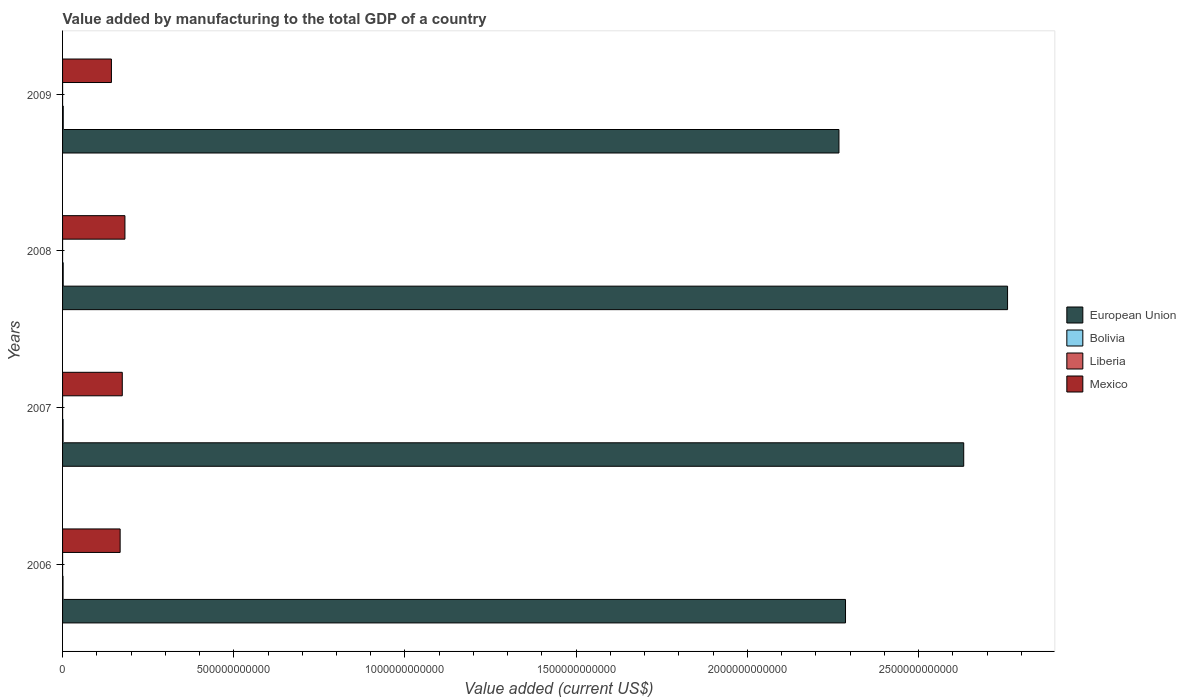How many different coloured bars are there?
Make the answer very short. 4. How many groups of bars are there?
Your answer should be very brief. 4. Are the number of bars per tick equal to the number of legend labels?
Provide a short and direct response. Yes. How many bars are there on the 3rd tick from the top?
Your response must be concise. 4. How many bars are there on the 4th tick from the bottom?
Provide a short and direct response. 4. What is the value added by manufacturing to the total GDP in Liberia in 2007?
Your answer should be compact. 5.42e+07. Across all years, what is the maximum value added by manufacturing to the total GDP in Liberia?
Your answer should be compact. 5.42e+07. Across all years, what is the minimum value added by manufacturing to the total GDP in Bolivia?
Make the answer very short. 1.30e+09. In which year was the value added by manufacturing to the total GDP in Bolivia minimum?
Make the answer very short. 2006. What is the total value added by manufacturing to the total GDP in Mexico in the graph?
Your answer should be very brief. 6.67e+11. What is the difference between the value added by manufacturing to the total GDP in Mexico in 2006 and that in 2009?
Your response must be concise. 2.54e+1. What is the difference between the value added by manufacturing to the total GDP in European Union in 2009 and the value added by manufacturing to the total GDP in Bolivia in 2008?
Ensure brevity in your answer.  2.27e+12. What is the average value added by manufacturing to the total GDP in European Union per year?
Ensure brevity in your answer.  2.49e+12. In the year 2008, what is the difference between the value added by manufacturing to the total GDP in Mexico and value added by manufacturing to the total GDP in European Union?
Keep it short and to the point. -2.58e+12. In how many years, is the value added by manufacturing to the total GDP in Bolivia greater than 1000000000000 US$?
Your answer should be compact. 0. What is the ratio of the value added by manufacturing to the total GDP in Bolivia in 2007 to that in 2009?
Provide a succinct answer. 0.74. What is the difference between the highest and the second highest value added by manufacturing to the total GDP in Mexico?
Offer a very short reply. 7.74e+09. What is the difference between the highest and the lowest value added by manufacturing to the total GDP in Liberia?
Keep it short and to the point. 8.43e+06. Is the sum of the value added by manufacturing to the total GDP in Bolivia in 2007 and 2008 greater than the maximum value added by manufacturing to the total GDP in European Union across all years?
Make the answer very short. No. What does the 3rd bar from the top in 2009 represents?
Provide a succinct answer. Bolivia. What does the 2nd bar from the bottom in 2007 represents?
Make the answer very short. Bolivia. Is it the case that in every year, the sum of the value added by manufacturing to the total GDP in Bolivia and value added by manufacturing to the total GDP in Mexico is greater than the value added by manufacturing to the total GDP in European Union?
Ensure brevity in your answer.  No. What is the difference between two consecutive major ticks on the X-axis?
Your answer should be compact. 5.00e+11. Are the values on the major ticks of X-axis written in scientific E-notation?
Your answer should be compact. No. How are the legend labels stacked?
Ensure brevity in your answer.  Vertical. What is the title of the graph?
Ensure brevity in your answer.  Value added by manufacturing to the total GDP of a country. Does "Suriname" appear as one of the legend labels in the graph?
Keep it short and to the point. No. What is the label or title of the X-axis?
Provide a short and direct response. Value added (current US$). What is the Value added (current US$) of European Union in 2006?
Offer a terse response. 2.29e+12. What is the Value added (current US$) in Bolivia in 2006?
Your response must be concise. 1.30e+09. What is the Value added (current US$) of Liberia in 2006?
Offer a very short reply. 4.58e+07. What is the Value added (current US$) in Mexico in 2006?
Your response must be concise. 1.68e+11. What is the Value added (current US$) in European Union in 2007?
Keep it short and to the point. 2.63e+12. What is the Value added (current US$) of Bolivia in 2007?
Provide a succinct answer. 1.50e+09. What is the Value added (current US$) of Liberia in 2007?
Ensure brevity in your answer.  5.42e+07. What is the Value added (current US$) of Mexico in 2007?
Your response must be concise. 1.74e+11. What is the Value added (current US$) of European Union in 2008?
Give a very brief answer. 2.76e+12. What is the Value added (current US$) in Bolivia in 2008?
Ensure brevity in your answer.  1.86e+09. What is the Value added (current US$) of Liberia in 2008?
Give a very brief answer. 5.11e+07. What is the Value added (current US$) in Mexico in 2008?
Offer a very short reply. 1.82e+11. What is the Value added (current US$) of European Union in 2009?
Your response must be concise. 2.27e+12. What is the Value added (current US$) in Bolivia in 2009?
Make the answer very short. 2.01e+09. What is the Value added (current US$) in Liberia in 2009?
Your answer should be compact. 4.96e+07. What is the Value added (current US$) of Mexico in 2009?
Ensure brevity in your answer.  1.43e+11. Across all years, what is the maximum Value added (current US$) of European Union?
Offer a very short reply. 2.76e+12. Across all years, what is the maximum Value added (current US$) in Bolivia?
Provide a succinct answer. 2.01e+09. Across all years, what is the maximum Value added (current US$) in Liberia?
Offer a terse response. 5.42e+07. Across all years, what is the maximum Value added (current US$) in Mexico?
Provide a short and direct response. 1.82e+11. Across all years, what is the minimum Value added (current US$) in European Union?
Offer a very short reply. 2.27e+12. Across all years, what is the minimum Value added (current US$) in Bolivia?
Your response must be concise. 1.30e+09. Across all years, what is the minimum Value added (current US$) of Liberia?
Keep it short and to the point. 4.58e+07. Across all years, what is the minimum Value added (current US$) in Mexico?
Give a very brief answer. 1.43e+11. What is the total Value added (current US$) in European Union in the graph?
Ensure brevity in your answer.  9.95e+12. What is the total Value added (current US$) of Bolivia in the graph?
Your answer should be compact. 6.67e+09. What is the total Value added (current US$) in Liberia in the graph?
Your response must be concise. 2.01e+08. What is the total Value added (current US$) of Mexico in the graph?
Your answer should be very brief. 6.67e+11. What is the difference between the Value added (current US$) of European Union in 2006 and that in 2007?
Keep it short and to the point. -3.45e+11. What is the difference between the Value added (current US$) of Bolivia in 2006 and that in 2007?
Offer a terse response. -2.00e+08. What is the difference between the Value added (current US$) of Liberia in 2006 and that in 2007?
Make the answer very short. -8.43e+06. What is the difference between the Value added (current US$) of Mexico in 2006 and that in 2007?
Give a very brief answer. -6.27e+09. What is the difference between the Value added (current US$) of European Union in 2006 and that in 2008?
Your response must be concise. -4.73e+11. What is the difference between the Value added (current US$) in Bolivia in 2006 and that in 2008?
Make the answer very short. -5.65e+08. What is the difference between the Value added (current US$) of Liberia in 2006 and that in 2008?
Provide a short and direct response. -5.27e+06. What is the difference between the Value added (current US$) in Mexico in 2006 and that in 2008?
Keep it short and to the point. -1.40e+1. What is the difference between the Value added (current US$) in European Union in 2006 and that in 2009?
Your response must be concise. 1.92e+1. What is the difference between the Value added (current US$) of Bolivia in 2006 and that in 2009?
Offer a terse response. -7.17e+08. What is the difference between the Value added (current US$) in Liberia in 2006 and that in 2009?
Keep it short and to the point. -3.84e+06. What is the difference between the Value added (current US$) of Mexico in 2006 and that in 2009?
Provide a short and direct response. 2.54e+1. What is the difference between the Value added (current US$) of European Union in 2007 and that in 2008?
Your answer should be very brief. -1.28e+11. What is the difference between the Value added (current US$) in Bolivia in 2007 and that in 2008?
Offer a very short reply. -3.65e+08. What is the difference between the Value added (current US$) of Liberia in 2007 and that in 2008?
Your answer should be compact. 3.16e+06. What is the difference between the Value added (current US$) in Mexico in 2007 and that in 2008?
Your answer should be very brief. -7.74e+09. What is the difference between the Value added (current US$) of European Union in 2007 and that in 2009?
Provide a short and direct response. 3.64e+11. What is the difference between the Value added (current US$) of Bolivia in 2007 and that in 2009?
Your answer should be compact. -5.17e+08. What is the difference between the Value added (current US$) of Liberia in 2007 and that in 2009?
Provide a succinct answer. 4.58e+06. What is the difference between the Value added (current US$) in Mexico in 2007 and that in 2009?
Keep it short and to the point. 3.17e+1. What is the difference between the Value added (current US$) in European Union in 2008 and that in 2009?
Keep it short and to the point. 4.93e+11. What is the difference between the Value added (current US$) of Bolivia in 2008 and that in 2009?
Provide a short and direct response. -1.52e+08. What is the difference between the Value added (current US$) in Liberia in 2008 and that in 2009?
Your answer should be compact. 1.42e+06. What is the difference between the Value added (current US$) in Mexico in 2008 and that in 2009?
Make the answer very short. 3.95e+1. What is the difference between the Value added (current US$) in European Union in 2006 and the Value added (current US$) in Bolivia in 2007?
Offer a very short reply. 2.29e+12. What is the difference between the Value added (current US$) of European Union in 2006 and the Value added (current US$) of Liberia in 2007?
Offer a terse response. 2.29e+12. What is the difference between the Value added (current US$) of European Union in 2006 and the Value added (current US$) of Mexico in 2007?
Your answer should be compact. 2.11e+12. What is the difference between the Value added (current US$) in Bolivia in 2006 and the Value added (current US$) in Liberia in 2007?
Ensure brevity in your answer.  1.24e+09. What is the difference between the Value added (current US$) of Bolivia in 2006 and the Value added (current US$) of Mexico in 2007?
Make the answer very short. -1.73e+11. What is the difference between the Value added (current US$) of Liberia in 2006 and the Value added (current US$) of Mexico in 2007?
Make the answer very short. -1.74e+11. What is the difference between the Value added (current US$) in European Union in 2006 and the Value added (current US$) in Bolivia in 2008?
Offer a very short reply. 2.28e+12. What is the difference between the Value added (current US$) in European Union in 2006 and the Value added (current US$) in Liberia in 2008?
Give a very brief answer. 2.29e+12. What is the difference between the Value added (current US$) of European Union in 2006 and the Value added (current US$) of Mexico in 2008?
Provide a short and direct response. 2.10e+12. What is the difference between the Value added (current US$) of Bolivia in 2006 and the Value added (current US$) of Liberia in 2008?
Make the answer very short. 1.25e+09. What is the difference between the Value added (current US$) of Bolivia in 2006 and the Value added (current US$) of Mexico in 2008?
Offer a terse response. -1.81e+11. What is the difference between the Value added (current US$) in Liberia in 2006 and the Value added (current US$) in Mexico in 2008?
Offer a terse response. -1.82e+11. What is the difference between the Value added (current US$) of European Union in 2006 and the Value added (current US$) of Bolivia in 2009?
Give a very brief answer. 2.28e+12. What is the difference between the Value added (current US$) of European Union in 2006 and the Value added (current US$) of Liberia in 2009?
Offer a very short reply. 2.29e+12. What is the difference between the Value added (current US$) in European Union in 2006 and the Value added (current US$) in Mexico in 2009?
Provide a succinct answer. 2.14e+12. What is the difference between the Value added (current US$) in Bolivia in 2006 and the Value added (current US$) in Liberia in 2009?
Offer a very short reply. 1.25e+09. What is the difference between the Value added (current US$) in Bolivia in 2006 and the Value added (current US$) in Mexico in 2009?
Your response must be concise. -1.41e+11. What is the difference between the Value added (current US$) in Liberia in 2006 and the Value added (current US$) in Mexico in 2009?
Your answer should be very brief. -1.43e+11. What is the difference between the Value added (current US$) of European Union in 2007 and the Value added (current US$) of Bolivia in 2008?
Make the answer very short. 2.63e+12. What is the difference between the Value added (current US$) in European Union in 2007 and the Value added (current US$) in Liberia in 2008?
Your response must be concise. 2.63e+12. What is the difference between the Value added (current US$) in European Union in 2007 and the Value added (current US$) in Mexico in 2008?
Give a very brief answer. 2.45e+12. What is the difference between the Value added (current US$) in Bolivia in 2007 and the Value added (current US$) in Liberia in 2008?
Your answer should be compact. 1.45e+09. What is the difference between the Value added (current US$) of Bolivia in 2007 and the Value added (current US$) of Mexico in 2008?
Provide a short and direct response. -1.81e+11. What is the difference between the Value added (current US$) in Liberia in 2007 and the Value added (current US$) in Mexico in 2008?
Your answer should be very brief. -1.82e+11. What is the difference between the Value added (current US$) of European Union in 2007 and the Value added (current US$) of Bolivia in 2009?
Offer a very short reply. 2.63e+12. What is the difference between the Value added (current US$) in European Union in 2007 and the Value added (current US$) in Liberia in 2009?
Your answer should be compact. 2.63e+12. What is the difference between the Value added (current US$) of European Union in 2007 and the Value added (current US$) of Mexico in 2009?
Keep it short and to the point. 2.49e+12. What is the difference between the Value added (current US$) of Bolivia in 2007 and the Value added (current US$) of Liberia in 2009?
Give a very brief answer. 1.45e+09. What is the difference between the Value added (current US$) of Bolivia in 2007 and the Value added (current US$) of Mexico in 2009?
Offer a terse response. -1.41e+11. What is the difference between the Value added (current US$) in Liberia in 2007 and the Value added (current US$) in Mexico in 2009?
Give a very brief answer. -1.43e+11. What is the difference between the Value added (current US$) of European Union in 2008 and the Value added (current US$) of Bolivia in 2009?
Your response must be concise. 2.76e+12. What is the difference between the Value added (current US$) of European Union in 2008 and the Value added (current US$) of Liberia in 2009?
Offer a terse response. 2.76e+12. What is the difference between the Value added (current US$) in European Union in 2008 and the Value added (current US$) in Mexico in 2009?
Give a very brief answer. 2.62e+12. What is the difference between the Value added (current US$) of Bolivia in 2008 and the Value added (current US$) of Liberia in 2009?
Your answer should be compact. 1.81e+09. What is the difference between the Value added (current US$) of Bolivia in 2008 and the Value added (current US$) of Mexico in 2009?
Your answer should be compact. -1.41e+11. What is the difference between the Value added (current US$) in Liberia in 2008 and the Value added (current US$) in Mexico in 2009?
Your answer should be compact. -1.43e+11. What is the average Value added (current US$) of European Union per year?
Offer a very short reply. 2.49e+12. What is the average Value added (current US$) in Bolivia per year?
Offer a terse response. 1.67e+09. What is the average Value added (current US$) in Liberia per year?
Your answer should be very brief. 5.02e+07. What is the average Value added (current US$) of Mexico per year?
Give a very brief answer. 1.67e+11. In the year 2006, what is the difference between the Value added (current US$) in European Union and Value added (current US$) in Bolivia?
Make the answer very short. 2.29e+12. In the year 2006, what is the difference between the Value added (current US$) of European Union and Value added (current US$) of Liberia?
Keep it short and to the point. 2.29e+12. In the year 2006, what is the difference between the Value added (current US$) in European Union and Value added (current US$) in Mexico?
Your answer should be compact. 2.12e+12. In the year 2006, what is the difference between the Value added (current US$) in Bolivia and Value added (current US$) in Liberia?
Provide a short and direct response. 1.25e+09. In the year 2006, what is the difference between the Value added (current US$) in Bolivia and Value added (current US$) in Mexico?
Your answer should be very brief. -1.67e+11. In the year 2006, what is the difference between the Value added (current US$) of Liberia and Value added (current US$) of Mexico?
Provide a succinct answer. -1.68e+11. In the year 2007, what is the difference between the Value added (current US$) in European Union and Value added (current US$) in Bolivia?
Provide a succinct answer. 2.63e+12. In the year 2007, what is the difference between the Value added (current US$) in European Union and Value added (current US$) in Liberia?
Your answer should be very brief. 2.63e+12. In the year 2007, what is the difference between the Value added (current US$) of European Union and Value added (current US$) of Mexico?
Your answer should be very brief. 2.46e+12. In the year 2007, what is the difference between the Value added (current US$) in Bolivia and Value added (current US$) in Liberia?
Ensure brevity in your answer.  1.44e+09. In the year 2007, what is the difference between the Value added (current US$) in Bolivia and Value added (current US$) in Mexico?
Ensure brevity in your answer.  -1.73e+11. In the year 2007, what is the difference between the Value added (current US$) in Liberia and Value added (current US$) in Mexico?
Ensure brevity in your answer.  -1.74e+11. In the year 2008, what is the difference between the Value added (current US$) of European Union and Value added (current US$) of Bolivia?
Provide a short and direct response. 2.76e+12. In the year 2008, what is the difference between the Value added (current US$) in European Union and Value added (current US$) in Liberia?
Your answer should be compact. 2.76e+12. In the year 2008, what is the difference between the Value added (current US$) of European Union and Value added (current US$) of Mexico?
Give a very brief answer. 2.58e+12. In the year 2008, what is the difference between the Value added (current US$) of Bolivia and Value added (current US$) of Liberia?
Keep it short and to the point. 1.81e+09. In the year 2008, what is the difference between the Value added (current US$) of Bolivia and Value added (current US$) of Mexico?
Your response must be concise. -1.80e+11. In the year 2008, what is the difference between the Value added (current US$) of Liberia and Value added (current US$) of Mexico?
Make the answer very short. -1.82e+11. In the year 2009, what is the difference between the Value added (current US$) in European Union and Value added (current US$) in Bolivia?
Keep it short and to the point. 2.27e+12. In the year 2009, what is the difference between the Value added (current US$) in European Union and Value added (current US$) in Liberia?
Keep it short and to the point. 2.27e+12. In the year 2009, what is the difference between the Value added (current US$) in European Union and Value added (current US$) in Mexico?
Your answer should be very brief. 2.12e+12. In the year 2009, what is the difference between the Value added (current US$) of Bolivia and Value added (current US$) of Liberia?
Give a very brief answer. 1.96e+09. In the year 2009, what is the difference between the Value added (current US$) in Bolivia and Value added (current US$) in Mexico?
Offer a very short reply. -1.41e+11. In the year 2009, what is the difference between the Value added (current US$) of Liberia and Value added (current US$) of Mexico?
Give a very brief answer. -1.43e+11. What is the ratio of the Value added (current US$) of European Union in 2006 to that in 2007?
Your response must be concise. 0.87. What is the ratio of the Value added (current US$) of Bolivia in 2006 to that in 2007?
Offer a very short reply. 0.87. What is the ratio of the Value added (current US$) of Liberia in 2006 to that in 2007?
Your response must be concise. 0.84. What is the ratio of the Value added (current US$) in Mexico in 2006 to that in 2007?
Ensure brevity in your answer.  0.96. What is the ratio of the Value added (current US$) in European Union in 2006 to that in 2008?
Your answer should be very brief. 0.83. What is the ratio of the Value added (current US$) of Bolivia in 2006 to that in 2008?
Offer a very short reply. 0.7. What is the ratio of the Value added (current US$) of Liberia in 2006 to that in 2008?
Provide a succinct answer. 0.9. What is the ratio of the Value added (current US$) of European Union in 2006 to that in 2009?
Offer a very short reply. 1.01. What is the ratio of the Value added (current US$) of Bolivia in 2006 to that in 2009?
Keep it short and to the point. 0.64. What is the ratio of the Value added (current US$) of Liberia in 2006 to that in 2009?
Keep it short and to the point. 0.92. What is the ratio of the Value added (current US$) of Mexico in 2006 to that in 2009?
Offer a very short reply. 1.18. What is the ratio of the Value added (current US$) in European Union in 2007 to that in 2008?
Keep it short and to the point. 0.95. What is the ratio of the Value added (current US$) of Bolivia in 2007 to that in 2008?
Your answer should be very brief. 0.8. What is the ratio of the Value added (current US$) of Liberia in 2007 to that in 2008?
Make the answer very short. 1.06. What is the ratio of the Value added (current US$) in Mexico in 2007 to that in 2008?
Ensure brevity in your answer.  0.96. What is the ratio of the Value added (current US$) of European Union in 2007 to that in 2009?
Ensure brevity in your answer.  1.16. What is the ratio of the Value added (current US$) in Bolivia in 2007 to that in 2009?
Provide a short and direct response. 0.74. What is the ratio of the Value added (current US$) in Liberia in 2007 to that in 2009?
Make the answer very short. 1.09. What is the ratio of the Value added (current US$) of Mexico in 2007 to that in 2009?
Give a very brief answer. 1.22. What is the ratio of the Value added (current US$) in European Union in 2008 to that in 2009?
Keep it short and to the point. 1.22. What is the ratio of the Value added (current US$) of Bolivia in 2008 to that in 2009?
Provide a succinct answer. 0.92. What is the ratio of the Value added (current US$) in Liberia in 2008 to that in 2009?
Ensure brevity in your answer.  1.03. What is the ratio of the Value added (current US$) of Mexico in 2008 to that in 2009?
Offer a very short reply. 1.28. What is the difference between the highest and the second highest Value added (current US$) of European Union?
Ensure brevity in your answer.  1.28e+11. What is the difference between the highest and the second highest Value added (current US$) in Bolivia?
Give a very brief answer. 1.52e+08. What is the difference between the highest and the second highest Value added (current US$) in Liberia?
Ensure brevity in your answer.  3.16e+06. What is the difference between the highest and the second highest Value added (current US$) in Mexico?
Keep it short and to the point. 7.74e+09. What is the difference between the highest and the lowest Value added (current US$) in European Union?
Your answer should be very brief. 4.93e+11. What is the difference between the highest and the lowest Value added (current US$) in Bolivia?
Your answer should be very brief. 7.17e+08. What is the difference between the highest and the lowest Value added (current US$) in Liberia?
Provide a succinct answer. 8.43e+06. What is the difference between the highest and the lowest Value added (current US$) in Mexico?
Provide a short and direct response. 3.95e+1. 